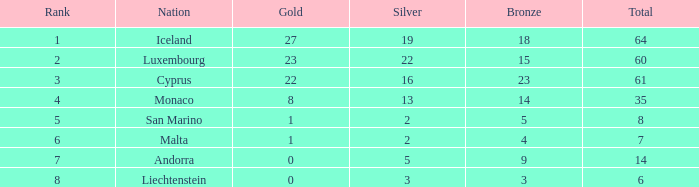How many bronzes for countries with more than 22 golds and ranking below 2? 18.0. 